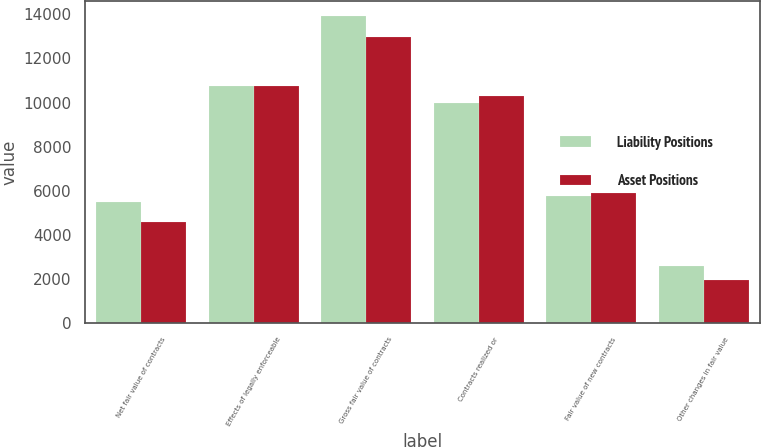Convert chart to OTSL. <chart><loc_0><loc_0><loc_500><loc_500><stacked_bar_chart><ecel><fcel>Net fair value of contracts<fcel>Effects of legally enforceable<fcel>Gross fair value of contracts<fcel>Contracts realized or<fcel>Fair value of new contracts<fcel>Other changes in fair value<nl><fcel>Liability Positions<fcel>5508<fcel>10756<fcel>13907<fcel>9976<fcel>5770<fcel>2584<nl><fcel>Asset Positions<fcel>4585<fcel>10756<fcel>12984<fcel>10300<fcel>5907<fcel>1944<nl></chart> 